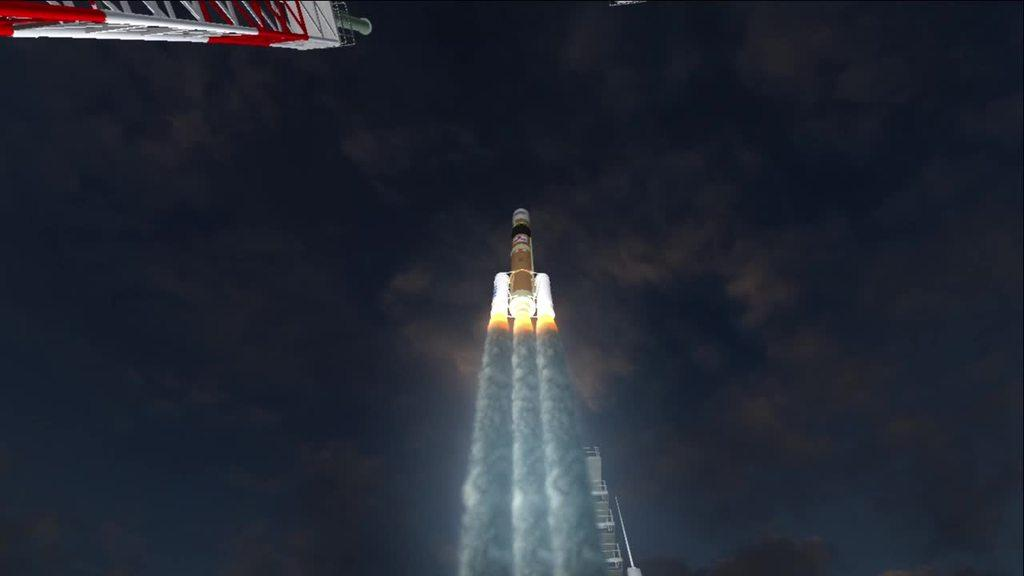What is in the sky in the image? There is a rocket in the sky in the image. What type of structure can be seen in the image? There is an iron tower in the image. What can be observed coming from the rocket or the iron tower? There is smoke visible in the image. What type of jar is being used to store the smoke in the image? There is no jar present in the image; the smoke is visible in the sky. 